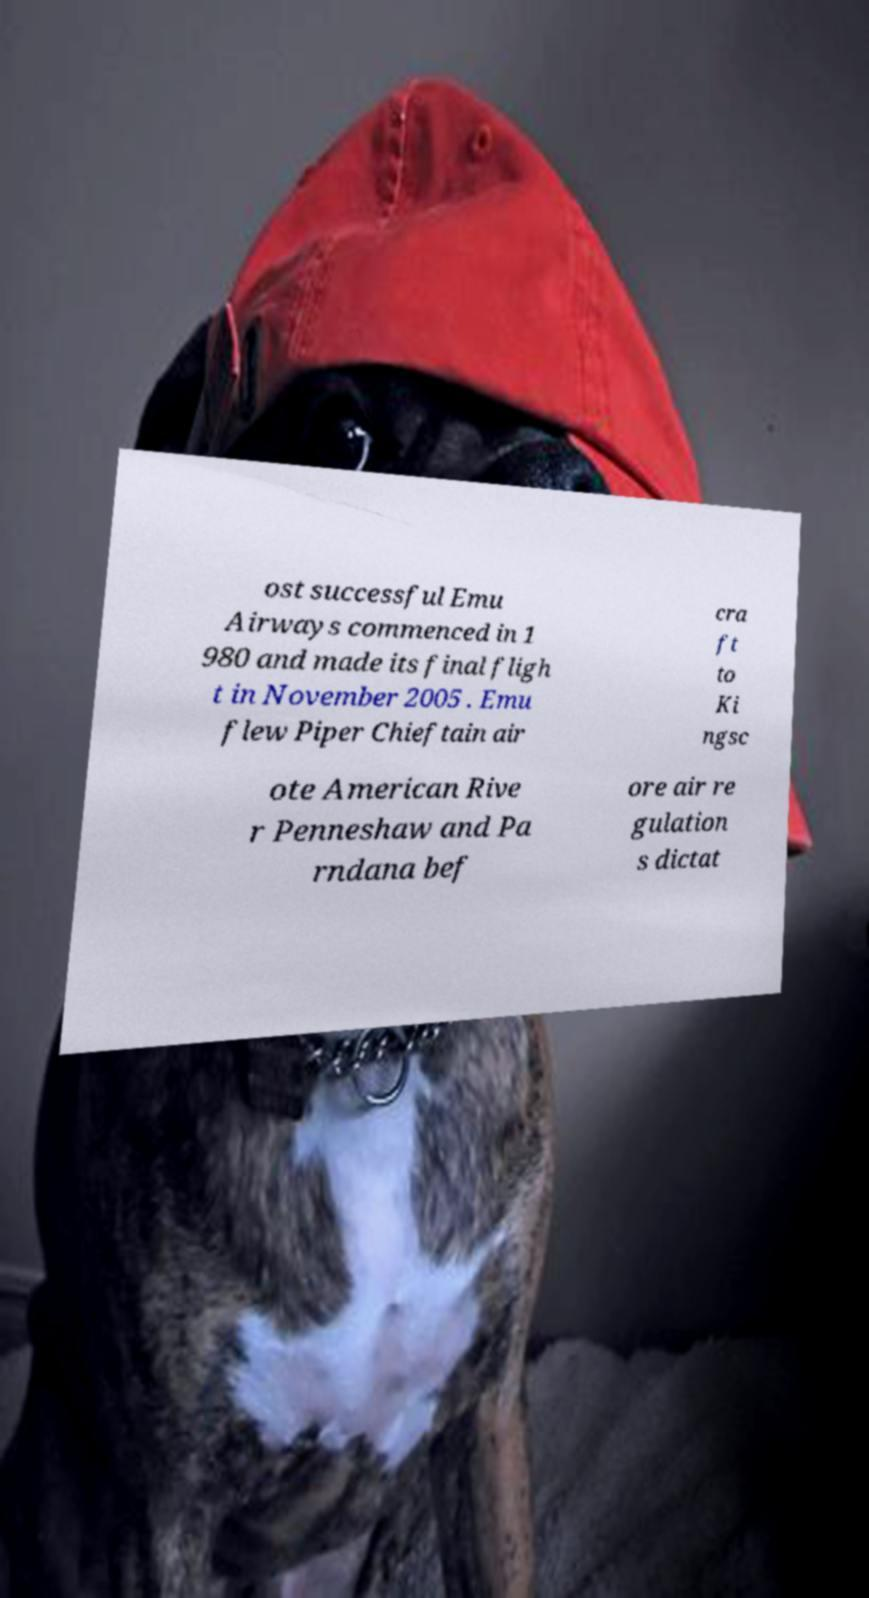There's text embedded in this image that I need extracted. Can you transcribe it verbatim? ost successful Emu Airways commenced in 1 980 and made its final fligh t in November 2005 . Emu flew Piper Chieftain air cra ft to Ki ngsc ote American Rive r Penneshaw and Pa rndana bef ore air re gulation s dictat 